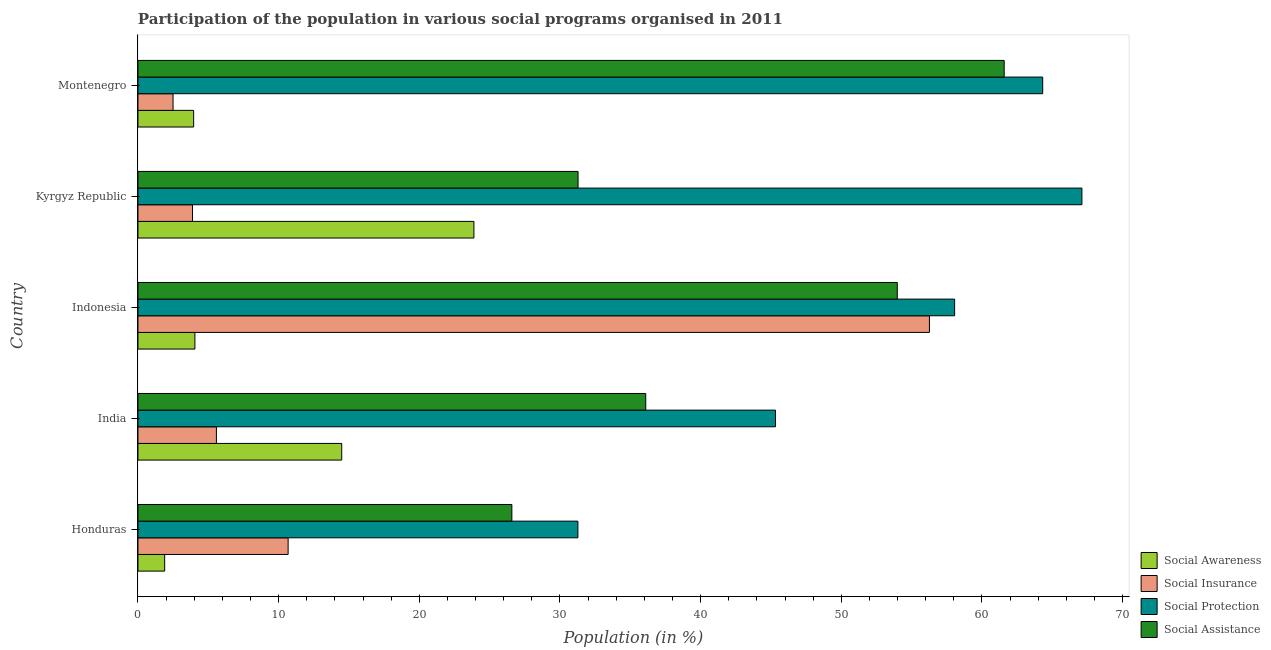How many different coloured bars are there?
Keep it short and to the point. 4. How many groups of bars are there?
Keep it short and to the point. 5. Are the number of bars on each tick of the Y-axis equal?
Provide a succinct answer. Yes. How many bars are there on the 3rd tick from the bottom?
Your answer should be compact. 4. What is the label of the 1st group of bars from the top?
Keep it short and to the point. Montenegro. In how many cases, is the number of bars for a given country not equal to the number of legend labels?
Your response must be concise. 0. What is the participation of population in social insurance programs in Honduras?
Your answer should be compact. 10.67. Across all countries, what is the maximum participation of population in social insurance programs?
Your answer should be compact. 56.27. Across all countries, what is the minimum participation of population in social protection programs?
Ensure brevity in your answer.  31.28. In which country was the participation of population in social protection programs maximum?
Your response must be concise. Kyrgyz Republic. In which country was the participation of population in social insurance programs minimum?
Your answer should be compact. Montenegro. What is the total participation of population in social awareness programs in the graph?
Give a very brief answer. 48.28. What is the difference between the participation of population in social protection programs in Indonesia and that in Kyrgyz Republic?
Keep it short and to the point. -9.05. What is the difference between the participation of population in social protection programs in Kyrgyz Republic and the participation of population in social awareness programs in India?
Provide a short and direct response. 52.62. What is the average participation of population in social insurance programs per country?
Make the answer very short. 15.78. What is the difference between the participation of population in social assistance programs and participation of population in social insurance programs in Indonesia?
Offer a terse response. -2.29. In how many countries, is the participation of population in social protection programs greater than 24 %?
Make the answer very short. 5. What is the ratio of the participation of population in social awareness programs in Honduras to that in Montenegro?
Keep it short and to the point. 0.48. Is the participation of population in social awareness programs in Indonesia less than that in Kyrgyz Republic?
Provide a succinct answer. Yes. What is the difference between the highest and the second highest participation of population in social assistance programs?
Provide a succinct answer. 7.6. In how many countries, is the participation of population in social insurance programs greater than the average participation of population in social insurance programs taken over all countries?
Provide a succinct answer. 1. Is the sum of the participation of population in social insurance programs in Honduras and Indonesia greater than the maximum participation of population in social assistance programs across all countries?
Offer a terse response. Yes. Is it the case that in every country, the sum of the participation of population in social insurance programs and participation of population in social assistance programs is greater than the sum of participation of population in social protection programs and participation of population in social awareness programs?
Ensure brevity in your answer.  No. What does the 2nd bar from the top in Indonesia represents?
Provide a short and direct response. Social Protection. What does the 2nd bar from the bottom in Honduras represents?
Offer a very short reply. Social Insurance. Is it the case that in every country, the sum of the participation of population in social awareness programs and participation of population in social insurance programs is greater than the participation of population in social protection programs?
Your answer should be very brief. No. How many bars are there?
Provide a succinct answer. 20. Are all the bars in the graph horizontal?
Provide a succinct answer. Yes. How many countries are there in the graph?
Your answer should be very brief. 5. What is the difference between two consecutive major ticks on the X-axis?
Keep it short and to the point. 10. Are the values on the major ticks of X-axis written in scientific E-notation?
Your response must be concise. No. Does the graph contain any zero values?
Offer a very short reply. No. Where does the legend appear in the graph?
Your answer should be compact. Bottom right. How many legend labels are there?
Offer a very short reply. 4. How are the legend labels stacked?
Your response must be concise. Vertical. What is the title of the graph?
Your answer should be compact. Participation of the population in various social programs organised in 2011. Does "Switzerland" appear as one of the legend labels in the graph?
Keep it short and to the point. No. What is the label or title of the X-axis?
Your answer should be compact. Population (in %). What is the label or title of the Y-axis?
Your answer should be very brief. Country. What is the Population (in %) in Social Awareness in Honduras?
Give a very brief answer. 1.9. What is the Population (in %) in Social Insurance in Honduras?
Keep it short and to the point. 10.67. What is the Population (in %) of Social Protection in Honduras?
Give a very brief answer. 31.28. What is the Population (in %) in Social Assistance in Honduras?
Your response must be concise. 26.58. What is the Population (in %) in Social Awareness in India?
Provide a succinct answer. 14.49. What is the Population (in %) of Social Insurance in India?
Your response must be concise. 5.58. What is the Population (in %) in Social Protection in India?
Give a very brief answer. 45.32. What is the Population (in %) of Social Assistance in India?
Provide a succinct answer. 36.1. What is the Population (in %) in Social Awareness in Indonesia?
Ensure brevity in your answer.  4.05. What is the Population (in %) of Social Insurance in Indonesia?
Your answer should be very brief. 56.27. What is the Population (in %) in Social Protection in Indonesia?
Offer a very short reply. 58.06. What is the Population (in %) of Social Assistance in Indonesia?
Give a very brief answer. 53.98. What is the Population (in %) of Social Awareness in Kyrgyz Republic?
Ensure brevity in your answer.  23.88. What is the Population (in %) of Social Insurance in Kyrgyz Republic?
Your response must be concise. 3.88. What is the Population (in %) of Social Protection in Kyrgyz Republic?
Your answer should be very brief. 67.11. What is the Population (in %) in Social Assistance in Kyrgyz Republic?
Provide a short and direct response. 31.29. What is the Population (in %) in Social Awareness in Montenegro?
Offer a very short reply. 3.96. What is the Population (in %) in Social Insurance in Montenegro?
Offer a very short reply. 2.49. What is the Population (in %) in Social Protection in Montenegro?
Your answer should be compact. 64.32. What is the Population (in %) in Social Assistance in Montenegro?
Your response must be concise. 61.58. Across all countries, what is the maximum Population (in %) of Social Awareness?
Offer a very short reply. 23.88. Across all countries, what is the maximum Population (in %) of Social Insurance?
Give a very brief answer. 56.27. Across all countries, what is the maximum Population (in %) of Social Protection?
Ensure brevity in your answer.  67.11. Across all countries, what is the maximum Population (in %) in Social Assistance?
Your response must be concise. 61.58. Across all countries, what is the minimum Population (in %) in Social Awareness?
Offer a very short reply. 1.9. Across all countries, what is the minimum Population (in %) of Social Insurance?
Ensure brevity in your answer.  2.49. Across all countries, what is the minimum Population (in %) in Social Protection?
Provide a succinct answer. 31.28. Across all countries, what is the minimum Population (in %) in Social Assistance?
Provide a short and direct response. 26.58. What is the total Population (in %) of Social Awareness in the graph?
Offer a terse response. 48.28. What is the total Population (in %) of Social Insurance in the graph?
Your response must be concise. 78.89. What is the total Population (in %) in Social Protection in the graph?
Make the answer very short. 266.08. What is the total Population (in %) of Social Assistance in the graph?
Provide a succinct answer. 209.52. What is the difference between the Population (in %) of Social Awareness in Honduras and that in India?
Offer a terse response. -12.59. What is the difference between the Population (in %) of Social Insurance in Honduras and that in India?
Offer a very short reply. 5.1. What is the difference between the Population (in %) in Social Protection in Honduras and that in India?
Offer a very short reply. -14.04. What is the difference between the Population (in %) in Social Assistance in Honduras and that in India?
Offer a very short reply. -9.52. What is the difference between the Population (in %) of Social Awareness in Honduras and that in Indonesia?
Provide a short and direct response. -2.15. What is the difference between the Population (in %) in Social Insurance in Honduras and that in Indonesia?
Offer a terse response. -45.59. What is the difference between the Population (in %) of Social Protection in Honduras and that in Indonesia?
Your answer should be very brief. -26.78. What is the difference between the Population (in %) of Social Assistance in Honduras and that in Indonesia?
Offer a very short reply. -27.4. What is the difference between the Population (in %) in Social Awareness in Honduras and that in Kyrgyz Republic?
Your answer should be very brief. -21.98. What is the difference between the Population (in %) in Social Insurance in Honduras and that in Kyrgyz Republic?
Make the answer very short. 6.8. What is the difference between the Population (in %) in Social Protection in Honduras and that in Kyrgyz Republic?
Your answer should be very brief. -35.83. What is the difference between the Population (in %) of Social Assistance in Honduras and that in Kyrgyz Republic?
Keep it short and to the point. -4.71. What is the difference between the Population (in %) in Social Awareness in Honduras and that in Montenegro?
Keep it short and to the point. -2.06. What is the difference between the Population (in %) of Social Insurance in Honduras and that in Montenegro?
Provide a succinct answer. 8.18. What is the difference between the Population (in %) of Social Protection in Honduras and that in Montenegro?
Keep it short and to the point. -33.04. What is the difference between the Population (in %) of Social Assistance in Honduras and that in Montenegro?
Offer a terse response. -35. What is the difference between the Population (in %) in Social Awareness in India and that in Indonesia?
Provide a succinct answer. 10.44. What is the difference between the Population (in %) in Social Insurance in India and that in Indonesia?
Your answer should be compact. -50.69. What is the difference between the Population (in %) of Social Protection in India and that in Indonesia?
Provide a short and direct response. -12.74. What is the difference between the Population (in %) in Social Assistance in India and that in Indonesia?
Offer a very short reply. -17.88. What is the difference between the Population (in %) of Social Awareness in India and that in Kyrgyz Republic?
Offer a terse response. -9.4. What is the difference between the Population (in %) of Social Insurance in India and that in Kyrgyz Republic?
Provide a succinct answer. 1.7. What is the difference between the Population (in %) of Social Protection in India and that in Kyrgyz Republic?
Offer a terse response. -21.79. What is the difference between the Population (in %) of Social Assistance in India and that in Kyrgyz Republic?
Make the answer very short. 4.81. What is the difference between the Population (in %) in Social Awareness in India and that in Montenegro?
Give a very brief answer. 10.53. What is the difference between the Population (in %) in Social Insurance in India and that in Montenegro?
Provide a succinct answer. 3.08. What is the difference between the Population (in %) of Social Protection in India and that in Montenegro?
Make the answer very short. -19. What is the difference between the Population (in %) in Social Assistance in India and that in Montenegro?
Keep it short and to the point. -25.48. What is the difference between the Population (in %) of Social Awareness in Indonesia and that in Kyrgyz Republic?
Your answer should be very brief. -19.84. What is the difference between the Population (in %) in Social Insurance in Indonesia and that in Kyrgyz Republic?
Your answer should be compact. 52.39. What is the difference between the Population (in %) of Social Protection in Indonesia and that in Kyrgyz Republic?
Give a very brief answer. -9.05. What is the difference between the Population (in %) in Social Assistance in Indonesia and that in Kyrgyz Republic?
Give a very brief answer. 22.69. What is the difference between the Population (in %) of Social Awareness in Indonesia and that in Montenegro?
Offer a very short reply. 0.09. What is the difference between the Population (in %) of Social Insurance in Indonesia and that in Montenegro?
Ensure brevity in your answer.  53.77. What is the difference between the Population (in %) of Social Protection in Indonesia and that in Montenegro?
Keep it short and to the point. -6.26. What is the difference between the Population (in %) in Social Assistance in Indonesia and that in Montenegro?
Your answer should be very brief. -7.6. What is the difference between the Population (in %) in Social Awareness in Kyrgyz Republic and that in Montenegro?
Your answer should be very brief. 19.92. What is the difference between the Population (in %) in Social Insurance in Kyrgyz Republic and that in Montenegro?
Ensure brevity in your answer.  1.38. What is the difference between the Population (in %) in Social Protection in Kyrgyz Republic and that in Montenegro?
Your answer should be very brief. 2.79. What is the difference between the Population (in %) in Social Assistance in Kyrgyz Republic and that in Montenegro?
Give a very brief answer. -30.29. What is the difference between the Population (in %) in Social Awareness in Honduras and the Population (in %) in Social Insurance in India?
Give a very brief answer. -3.68. What is the difference between the Population (in %) in Social Awareness in Honduras and the Population (in %) in Social Protection in India?
Your answer should be compact. -43.42. What is the difference between the Population (in %) in Social Awareness in Honduras and the Population (in %) in Social Assistance in India?
Your answer should be compact. -34.2. What is the difference between the Population (in %) in Social Insurance in Honduras and the Population (in %) in Social Protection in India?
Your response must be concise. -34.65. What is the difference between the Population (in %) in Social Insurance in Honduras and the Population (in %) in Social Assistance in India?
Provide a short and direct response. -25.42. What is the difference between the Population (in %) of Social Protection in Honduras and the Population (in %) of Social Assistance in India?
Give a very brief answer. -4.82. What is the difference between the Population (in %) in Social Awareness in Honduras and the Population (in %) in Social Insurance in Indonesia?
Offer a terse response. -54.37. What is the difference between the Population (in %) in Social Awareness in Honduras and the Population (in %) in Social Protection in Indonesia?
Ensure brevity in your answer.  -56.16. What is the difference between the Population (in %) of Social Awareness in Honduras and the Population (in %) of Social Assistance in Indonesia?
Keep it short and to the point. -52.08. What is the difference between the Population (in %) of Social Insurance in Honduras and the Population (in %) of Social Protection in Indonesia?
Keep it short and to the point. -47.38. What is the difference between the Population (in %) of Social Insurance in Honduras and the Population (in %) of Social Assistance in Indonesia?
Offer a terse response. -43.3. What is the difference between the Population (in %) in Social Protection in Honduras and the Population (in %) in Social Assistance in Indonesia?
Provide a succinct answer. -22.7. What is the difference between the Population (in %) of Social Awareness in Honduras and the Population (in %) of Social Insurance in Kyrgyz Republic?
Keep it short and to the point. -1.98. What is the difference between the Population (in %) of Social Awareness in Honduras and the Population (in %) of Social Protection in Kyrgyz Republic?
Your answer should be compact. -65.21. What is the difference between the Population (in %) of Social Awareness in Honduras and the Population (in %) of Social Assistance in Kyrgyz Republic?
Your answer should be very brief. -29.39. What is the difference between the Population (in %) in Social Insurance in Honduras and the Population (in %) in Social Protection in Kyrgyz Republic?
Offer a terse response. -56.43. What is the difference between the Population (in %) in Social Insurance in Honduras and the Population (in %) in Social Assistance in Kyrgyz Republic?
Keep it short and to the point. -20.61. What is the difference between the Population (in %) of Social Protection in Honduras and the Population (in %) of Social Assistance in Kyrgyz Republic?
Offer a terse response. -0.01. What is the difference between the Population (in %) in Social Awareness in Honduras and the Population (in %) in Social Insurance in Montenegro?
Offer a very short reply. -0.59. What is the difference between the Population (in %) of Social Awareness in Honduras and the Population (in %) of Social Protection in Montenegro?
Ensure brevity in your answer.  -62.42. What is the difference between the Population (in %) of Social Awareness in Honduras and the Population (in %) of Social Assistance in Montenegro?
Make the answer very short. -59.68. What is the difference between the Population (in %) in Social Insurance in Honduras and the Population (in %) in Social Protection in Montenegro?
Give a very brief answer. -53.64. What is the difference between the Population (in %) in Social Insurance in Honduras and the Population (in %) in Social Assistance in Montenegro?
Give a very brief answer. -50.9. What is the difference between the Population (in %) in Social Protection in Honduras and the Population (in %) in Social Assistance in Montenegro?
Make the answer very short. -30.3. What is the difference between the Population (in %) in Social Awareness in India and the Population (in %) in Social Insurance in Indonesia?
Provide a short and direct response. -41.78. What is the difference between the Population (in %) in Social Awareness in India and the Population (in %) in Social Protection in Indonesia?
Make the answer very short. -43.57. What is the difference between the Population (in %) of Social Awareness in India and the Population (in %) of Social Assistance in Indonesia?
Your answer should be very brief. -39.49. What is the difference between the Population (in %) of Social Insurance in India and the Population (in %) of Social Protection in Indonesia?
Provide a succinct answer. -52.48. What is the difference between the Population (in %) of Social Insurance in India and the Population (in %) of Social Assistance in Indonesia?
Your response must be concise. -48.4. What is the difference between the Population (in %) in Social Protection in India and the Population (in %) in Social Assistance in Indonesia?
Offer a very short reply. -8.66. What is the difference between the Population (in %) in Social Awareness in India and the Population (in %) in Social Insurance in Kyrgyz Republic?
Keep it short and to the point. 10.61. What is the difference between the Population (in %) in Social Awareness in India and the Population (in %) in Social Protection in Kyrgyz Republic?
Keep it short and to the point. -52.62. What is the difference between the Population (in %) of Social Awareness in India and the Population (in %) of Social Assistance in Kyrgyz Republic?
Your answer should be compact. -16.8. What is the difference between the Population (in %) of Social Insurance in India and the Population (in %) of Social Protection in Kyrgyz Republic?
Your response must be concise. -61.53. What is the difference between the Population (in %) in Social Insurance in India and the Population (in %) in Social Assistance in Kyrgyz Republic?
Give a very brief answer. -25.71. What is the difference between the Population (in %) of Social Protection in India and the Population (in %) of Social Assistance in Kyrgyz Republic?
Give a very brief answer. 14.03. What is the difference between the Population (in %) of Social Awareness in India and the Population (in %) of Social Insurance in Montenegro?
Your response must be concise. 11.99. What is the difference between the Population (in %) of Social Awareness in India and the Population (in %) of Social Protection in Montenegro?
Make the answer very short. -49.83. What is the difference between the Population (in %) of Social Awareness in India and the Population (in %) of Social Assistance in Montenegro?
Offer a very short reply. -47.09. What is the difference between the Population (in %) of Social Insurance in India and the Population (in %) of Social Protection in Montenegro?
Make the answer very short. -58.74. What is the difference between the Population (in %) of Social Insurance in India and the Population (in %) of Social Assistance in Montenegro?
Your answer should be compact. -56. What is the difference between the Population (in %) of Social Protection in India and the Population (in %) of Social Assistance in Montenegro?
Provide a short and direct response. -16.26. What is the difference between the Population (in %) in Social Awareness in Indonesia and the Population (in %) in Social Insurance in Kyrgyz Republic?
Offer a terse response. 0.17. What is the difference between the Population (in %) in Social Awareness in Indonesia and the Population (in %) in Social Protection in Kyrgyz Republic?
Provide a short and direct response. -63.06. What is the difference between the Population (in %) of Social Awareness in Indonesia and the Population (in %) of Social Assistance in Kyrgyz Republic?
Your response must be concise. -27.24. What is the difference between the Population (in %) of Social Insurance in Indonesia and the Population (in %) of Social Protection in Kyrgyz Republic?
Your response must be concise. -10.84. What is the difference between the Population (in %) in Social Insurance in Indonesia and the Population (in %) in Social Assistance in Kyrgyz Republic?
Give a very brief answer. 24.98. What is the difference between the Population (in %) of Social Protection in Indonesia and the Population (in %) of Social Assistance in Kyrgyz Republic?
Your answer should be very brief. 26.77. What is the difference between the Population (in %) of Social Awareness in Indonesia and the Population (in %) of Social Insurance in Montenegro?
Provide a short and direct response. 1.55. What is the difference between the Population (in %) in Social Awareness in Indonesia and the Population (in %) in Social Protection in Montenegro?
Give a very brief answer. -60.27. What is the difference between the Population (in %) of Social Awareness in Indonesia and the Population (in %) of Social Assistance in Montenegro?
Your answer should be very brief. -57.53. What is the difference between the Population (in %) of Social Insurance in Indonesia and the Population (in %) of Social Protection in Montenegro?
Provide a short and direct response. -8.05. What is the difference between the Population (in %) in Social Insurance in Indonesia and the Population (in %) in Social Assistance in Montenegro?
Provide a short and direct response. -5.31. What is the difference between the Population (in %) in Social Protection in Indonesia and the Population (in %) in Social Assistance in Montenegro?
Your answer should be compact. -3.52. What is the difference between the Population (in %) of Social Awareness in Kyrgyz Republic and the Population (in %) of Social Insurance in Montenegro?
Provide a succinct answer. 21.39. What is the difference between the Population (in %) in Social Awareness in Kyrgyz Republic and the Population (in %) in Social Protection in Montenegro?
Make the answer very short. -40.44. What is the difference between the Population (in %) of Social Awareness in Kyrgyz Republic and the Population (in %) of Social Assistance in Montenegro?
Offer a very short reply. -37.7. What is the difference between the Population (in %) of Social Insurance in Kyrgyz Republic and the Population (in %) of Social Protection in Montenegro?
Your answer should be very brief. -60.44. What is the difference between the Population (in %) of Social Insurance in Kyrgyz Republic and the Population (in %) of Social Assistance in Montenegro?
Give a very brief answer. -57.7. What is the difference between the Population (in %) in Social Protection in Kyrgyz Republic and the Population (in %) in Social Assistance in Montenegro?
Your answer should be very brief. 5.53. What is the average Population (in %) of Social Awareness per country?
Your answer should be very brief. 9.66. What is the average Population (in %) of Social Insurance per country?
Keep it short and to the point. 15.78. What is the average Population (in %) of Social Protection per country?
Your answer should be compact. 53.22. What is the average Population (in %) in Social Assistance per country?
Keep it short and to the point. 41.9. What is the difference between the Population (in %) of Social Awareness and Population (in %) of Social Insurance in Honduras?
Offer a terse response. -8.78. What is the difference between the Population (in %) of Social Awareness and Population (in %) of Social Protection in Honduras?
Provide a short and direct response. -29.38. What is the difference between the Population (in %) of Social Awareness and Population (in %) of Social Assistance in Honduras?
Keep it short and to the point. -24.68. What is the difference between the Population (in %) of Social Insurance and Population (in %) of Social Protection in Honduras?
Offer a terse response. -20.6. What is the difference between the Population (in %) of Social Insurance and Population (in %) of Social Assistance in Honduras?
Your answer should be compact. -15.91. What is the difference between the Population (in %) in Social Protection and Population (in %) in Social Assistance in Honduras?
Give a very brief answer. 4.7. What is the difference between the Population (in %) in Social Awareness and Population (in %) in Social Insurance in India?
Offer a very short reply. 8.91. What is the difference between the Population (in %) of Social Awareness and Population (in %) of Social Protection in India?
Give a very brief answer. -30.84. What is the difference between the Population (in %) of Social Awareness and Population (in %) of Social Assistance in India?
Provide a short and direct response. -21.61. What is the difference between the Population (in %) of Social Insurance and Population (in %) of Social Protection in India?
Provide a succinct answer. -39.74. What is the difference between the Population (in %) in Social Insurance and Population (in %) in Social Assistance in India?
Your response must be concise. -30.52. What is the difference between the Population (in %) in Social Protection and Population (in %) in Social Assistance in India?
Keep it short and to the point. 9.22. What is the difference between the Population (in %) in Social Awareness and Population (in %) in Social Insurance in Indonesia?
Keep it short and to the point. -52.22. What is the difference between the Population (in %) of Social Awareness and Population (in %) of Social Protection in Indonesia?
Ensure brevity in your answer.  -54.01. What is the difference between the Population (in %) of Social Awareness and Population (in %) of Social Assistance in Indonesia?
Keep it short and to the point. -49.93. What is the difference between the Population (in %) of Social Insurance and Population (in %) of Social Protection in Indonesia?
Provide a short and direct response. -1.79. What is the difference between the Population (in %) of Social Insurance and Population (in %) of Social Assistance in Indonesia?
Provide a succinct answer. 2.29. What is the difference between the Population (in %) of Social Protection and Population (in %) of Social Assistance in Indonesia?
Keep it short and to the point. 4.08. What is the difference between the Population (in %) of Social Awareness and Population (in %) of Social Insurance in Kyrgyz Republic?
Provide a short and direct response. 20.01. What is the difference between the Population (in %) in Social Awareness and Population (in %) in Social Protection in Kyrgyz Republic?
Give a very brief answer. -43.22. What is the difference between the Population (in %) of Social Awareness and Population (in %) of Social Assistance in Kyrgyz Republic?
Your answer should be compact. -7.4. What is the difference between the Population (in %) in Social Insurance and Population (in %) in Social Protection in Kyrgyz Republic?
Provide a succinct answer. -63.23. What is the difference between the Population (in %) of Social Insurance and Population (in %) of Social Assistance in Kyrgyz Republic?
Give a very brief answer. -27.41. What is the difference between the Population (in %) in Social Protection and Population (in %) in Social Assistance in Kyrgyz Republic?
Give a very brief answer. 35.82. What is the difference between the Population (in %) in Social Awareness and Population (in %) in Social Insurance in Montenegro?
Provide a succinct answer. 1.47. What is the difference between the Population (in %) in Social Awareness and Population (in %) in Social Protection in Montenegro?
Your answer should be very brief. -60.36. What is the difference between the Population (in %) of Social Awareness and Population (in %) of Social Assistance in Montenegro?
Give a very brief answer. -57.62. What is the difference between the Population (in %) of Social Insurance and Population (in %) of Social Protection in Montenegro?
Offer a terse response. -61.82. What is the difference between the Population (in %) of Social Insurance and Population (in %) of Social Assistance in Montenegro?
Provide a short and direct response. -59.09. What is the difference between the Population (in %) of Social Protection and Population (in %) of Social Assistance in Montenegro?
Provide a succinct answer. 2.74. What is the ratio of the Population (in %) in Social Awareness in Honduras to that in India?
Your answer should be very brief. 0.13. What is the ratio of the Population (in %) in Social Insurance in Honduras to that in India?
Your response must be concise. 1.91. What is the ratio of the Population (in %) in Social Protection in Honduras to that in India?
Provide a short and direct response. 0.69. What is the ratio of the Population (in %) of Social Assistance in Honduras to that in India?
Provide a short and direct response. 0.74. What is the ratio of the Population (in %) of Social Awareness in Honduras to that in Indonesia?
Provide a short and direct response. 0.47. What is the ratio of the Population (in %) in Social Insurance in Honduras to that in Indonesia?
Your answer should be very brief. 0.19. What is the ratio of the Population (in %) in Social Protection in Honduras to that in Indonesia?
Make the answer very short. 0.54. What is the ratio of the Population (in %) in Social Assistance in Honduras to that in Indonesia?
Keep it short and to the point. 0.49. What is the ratio of the Population (in %) in Social Awareness in Honduras to that in Kyrgyz Republic?
Make the answer very short. 0.08. What is the ratio of the Population (in %) in Social Insurance in Honduras to that in Kyrgyz Republic?
Your answer should be compact. 2.75. What is the ratio of the Population (in %) of Social Protection in Honduras to that in Kyrgyz Republic?
Offer a terse response. 0.47. What is the ratio of the Population (in %) in Social Assistance in Honduras to that in Kyrgyz Republic?
Your response must be concise. 0.85. What is the ratio of the Population (in %) of Social Awareness in Honduras to that in Montenegro?
Your response must be concise. 0.48. What is the ratio of the Population (in %) in Social Insurance in Honduras to that in Montenegro?
Keep it short and to the point. 4.28. What is the ratio of the Population (in %) of Social Protection in Honduras to that in Montenegro?
Your response must be concise. 0.49. What is the ratio of the Population (in %) of Social Assistance in Honduras to that in Montenegro?
Keep it short and to the point. 0.43. What is the ratio of the Population (in %) in Social Awareness in India to that in Indonesia?
Ensure brevity in your answer.  3.58. What is the ratio of the Population (in %) in Social Insurance in India to that in Indonesia?
Provide a succinct answer. 0.1. What is the ratio of the Population (in %) of Social Protection in India to that in Indonesia?
Your response must be concise. 0.78. What is the ratio of the Population (in %) in Social Assistance in India to that in Indonesia?
Offer a terse response. 0.67. What is the ratio of the Population (in %) of Social Awareness in India to that in Kyrgyz Republic?
Provide a succinct answer. 0.61. What is the ratio of the Population (in %) in Social Insurance in India to that in Kyrgyz Republic?
Give a very brief answer. 1.44. What is the ratio of the Population (in %) of Social Protection in India to that in Kyrgyz Republic?
Make the answer very short. 0.68. What is the ratio of the Population (in %) of Social Assistance in India to that in Kyrgyz Republic?
Make the answer very short. 1.15. What is the ratio of the Population (in %) in Social Awareness in India to that in Montenegro?
Provide a short and direct response. 3.66. What is the ratio of the Population (in %) in Social Insurance in India to that in Montenegro?
Your answer should be very brief. 2.24. What is the ratio of the Population (in %) of Social Protection in India to that in Montenegro?
Provide a short and direct response. 0.7. What is the ratio of the Population (in %) in Social Assistance in India to that in Montenegro?
Give a very brief answer. 0.59. What is the ratio of the Population (in %) in Social Awareness in Indonesia to that in Kyrgyz Republic?
Your answer should be compact. 0.17. What is the ratio of the Population (in %) in Social Insurance in Indonesia to that in Kyrgyz Republic?
Offer a very short reply. 14.51. What is the ratio of the Population (in %) in Social Protection in Indonesia to that in Kyrgyz Republic?
Make the answer very short. 0.87. What is the ratio of the Population (in %) of Social Assistance in Indonesia to that in Kyrgyz Republic?
Your answer should be compact. 1.73. What is the ratio of the Population (in %) in Social Awareness in Indonesia to that in Montenegro?
Keep it short and to the point. 1.02. What is the ratio of the Population (in %) of Social Insurance in Indonesia to that in Montenegro?
Give a very brief answer. 22.56. What is the ratio of the Population (in %) in Social Protection in Indonesia to that in Montenegro?
Keep it short and to the point. 0.9. What is the ratio of the Population (in %) of Social Assistance in Indonesia to that in Montenegro?
Offer a terse response. 0.88. What is the ratio of the Population (in %) of Social Awareness in Kyrgyz Republic to that in Montenegro?
Keep it short and to the point. 6.03. What is the ratio of the Population (in %) of Social Insurance in Kyrgyz Republic to that in Montenegro?
Offer a very short reply. 1.55. What is the ratio of the Population (in %) of Social Protection in Kyrgyz Republic to that in Montenegro?
Offer a terse response. 1.04. What is the ratio of the Population (in %) in Social Assistance in Kyrgyz Republic to that in Montenegro?
Your response must be concise. 0.51. What is the difference between the highest and the second highest Population (in %) of Social Awareness?
Your response must be concise. 9.4. What is the difference between the highest and the second highest Population (in %) of Social Insurance?
Offer a terse response. 45.59. What is the difference between the highest and the second highest Population (in %) in Social Protection?
Your response must be concise. 2.79. What is the difference between the highest and the second highest Population (in %) of Social Assistance?
Your answer should be very brief. 7.6. What is the difference between the highest and the lowest Population (in %) of Social Awareness?
Provide a short and direct response. 21.98. What is the difference between the highest and the lowest Population (in %) in Social Insurance?
Make the answer very short. 53.77. What is the difference between the highest and the lowest Population (in %) of Social Protection?
Provide a succinct answer. 35.83. What is the difference between the highest and the lowest Population (in %) in Social Assistance?
Give a very brief answer. 35. 